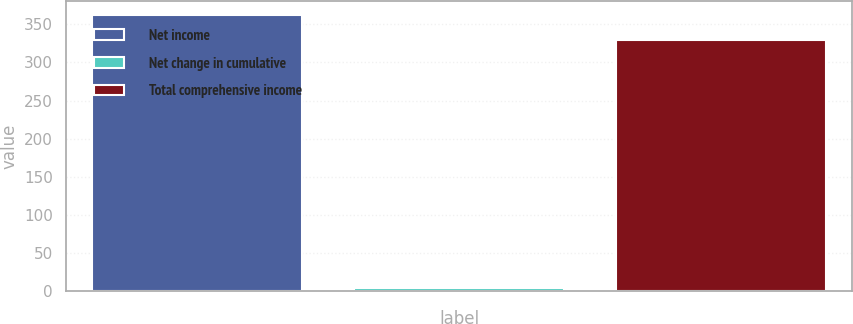<chart> <loc_0><loc_0><loc_500><loc_500><bar_chart><fcel>Net income<fcel>Net change in cumulative<fcel>Total comprehensive income<nl><fcel>361.9<fcel>4.6<fcel>329<nl></chart> 